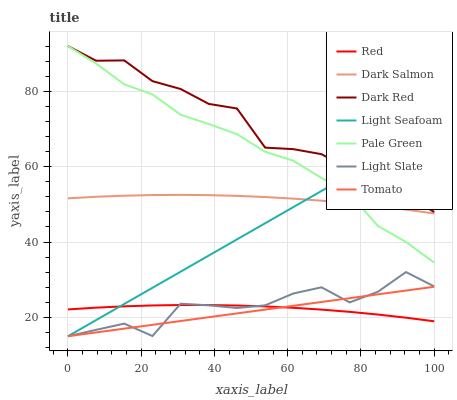Does Tomato have the minimum area under the curve?
Answer yes or no. Yes. Does Dark Red have the maximum area under the curve?
Answer yes or no. Yes. Does Light Slate have the minimum area under the curve?
Answer yes or no. No. Does Light Slate have the maximum area under the curve?
Answer yes or no. No. Is Tomato the smoothest?
Answer yes or no. Yes. Is Light Slate the roughest?
Answer yes or no. Yes. Is Dark Red the smoothest?
Answer yes or no. No. Is Dark Red the roughest?
Answer yes or no. No. Does Tomato have the lowest value?
Answer yes or no. Yes. Does Dark Red have the lowest value?
Answer yes or no. No. Does Pale Green have the highest value?
Answer yes or no. Yes. Does Light Slate have the highest value?
Answer yes or no. No. Is Red less than Dark Salmon?
Answer yes or no. Yes. Is Dark Red greater than Dark Salmon?
Answer yes or no. Yes. Does Dark Red intersect Light Seafoam?
Answer yes or no. Yes. Is Dark Red less than Light Seafoam?
Answer yes or no. No. Is Dark Red greater than Light Seafoam?
Answer yes or no. No. Does Red intersect Dark Salmon?
Answer yes or no. No. 